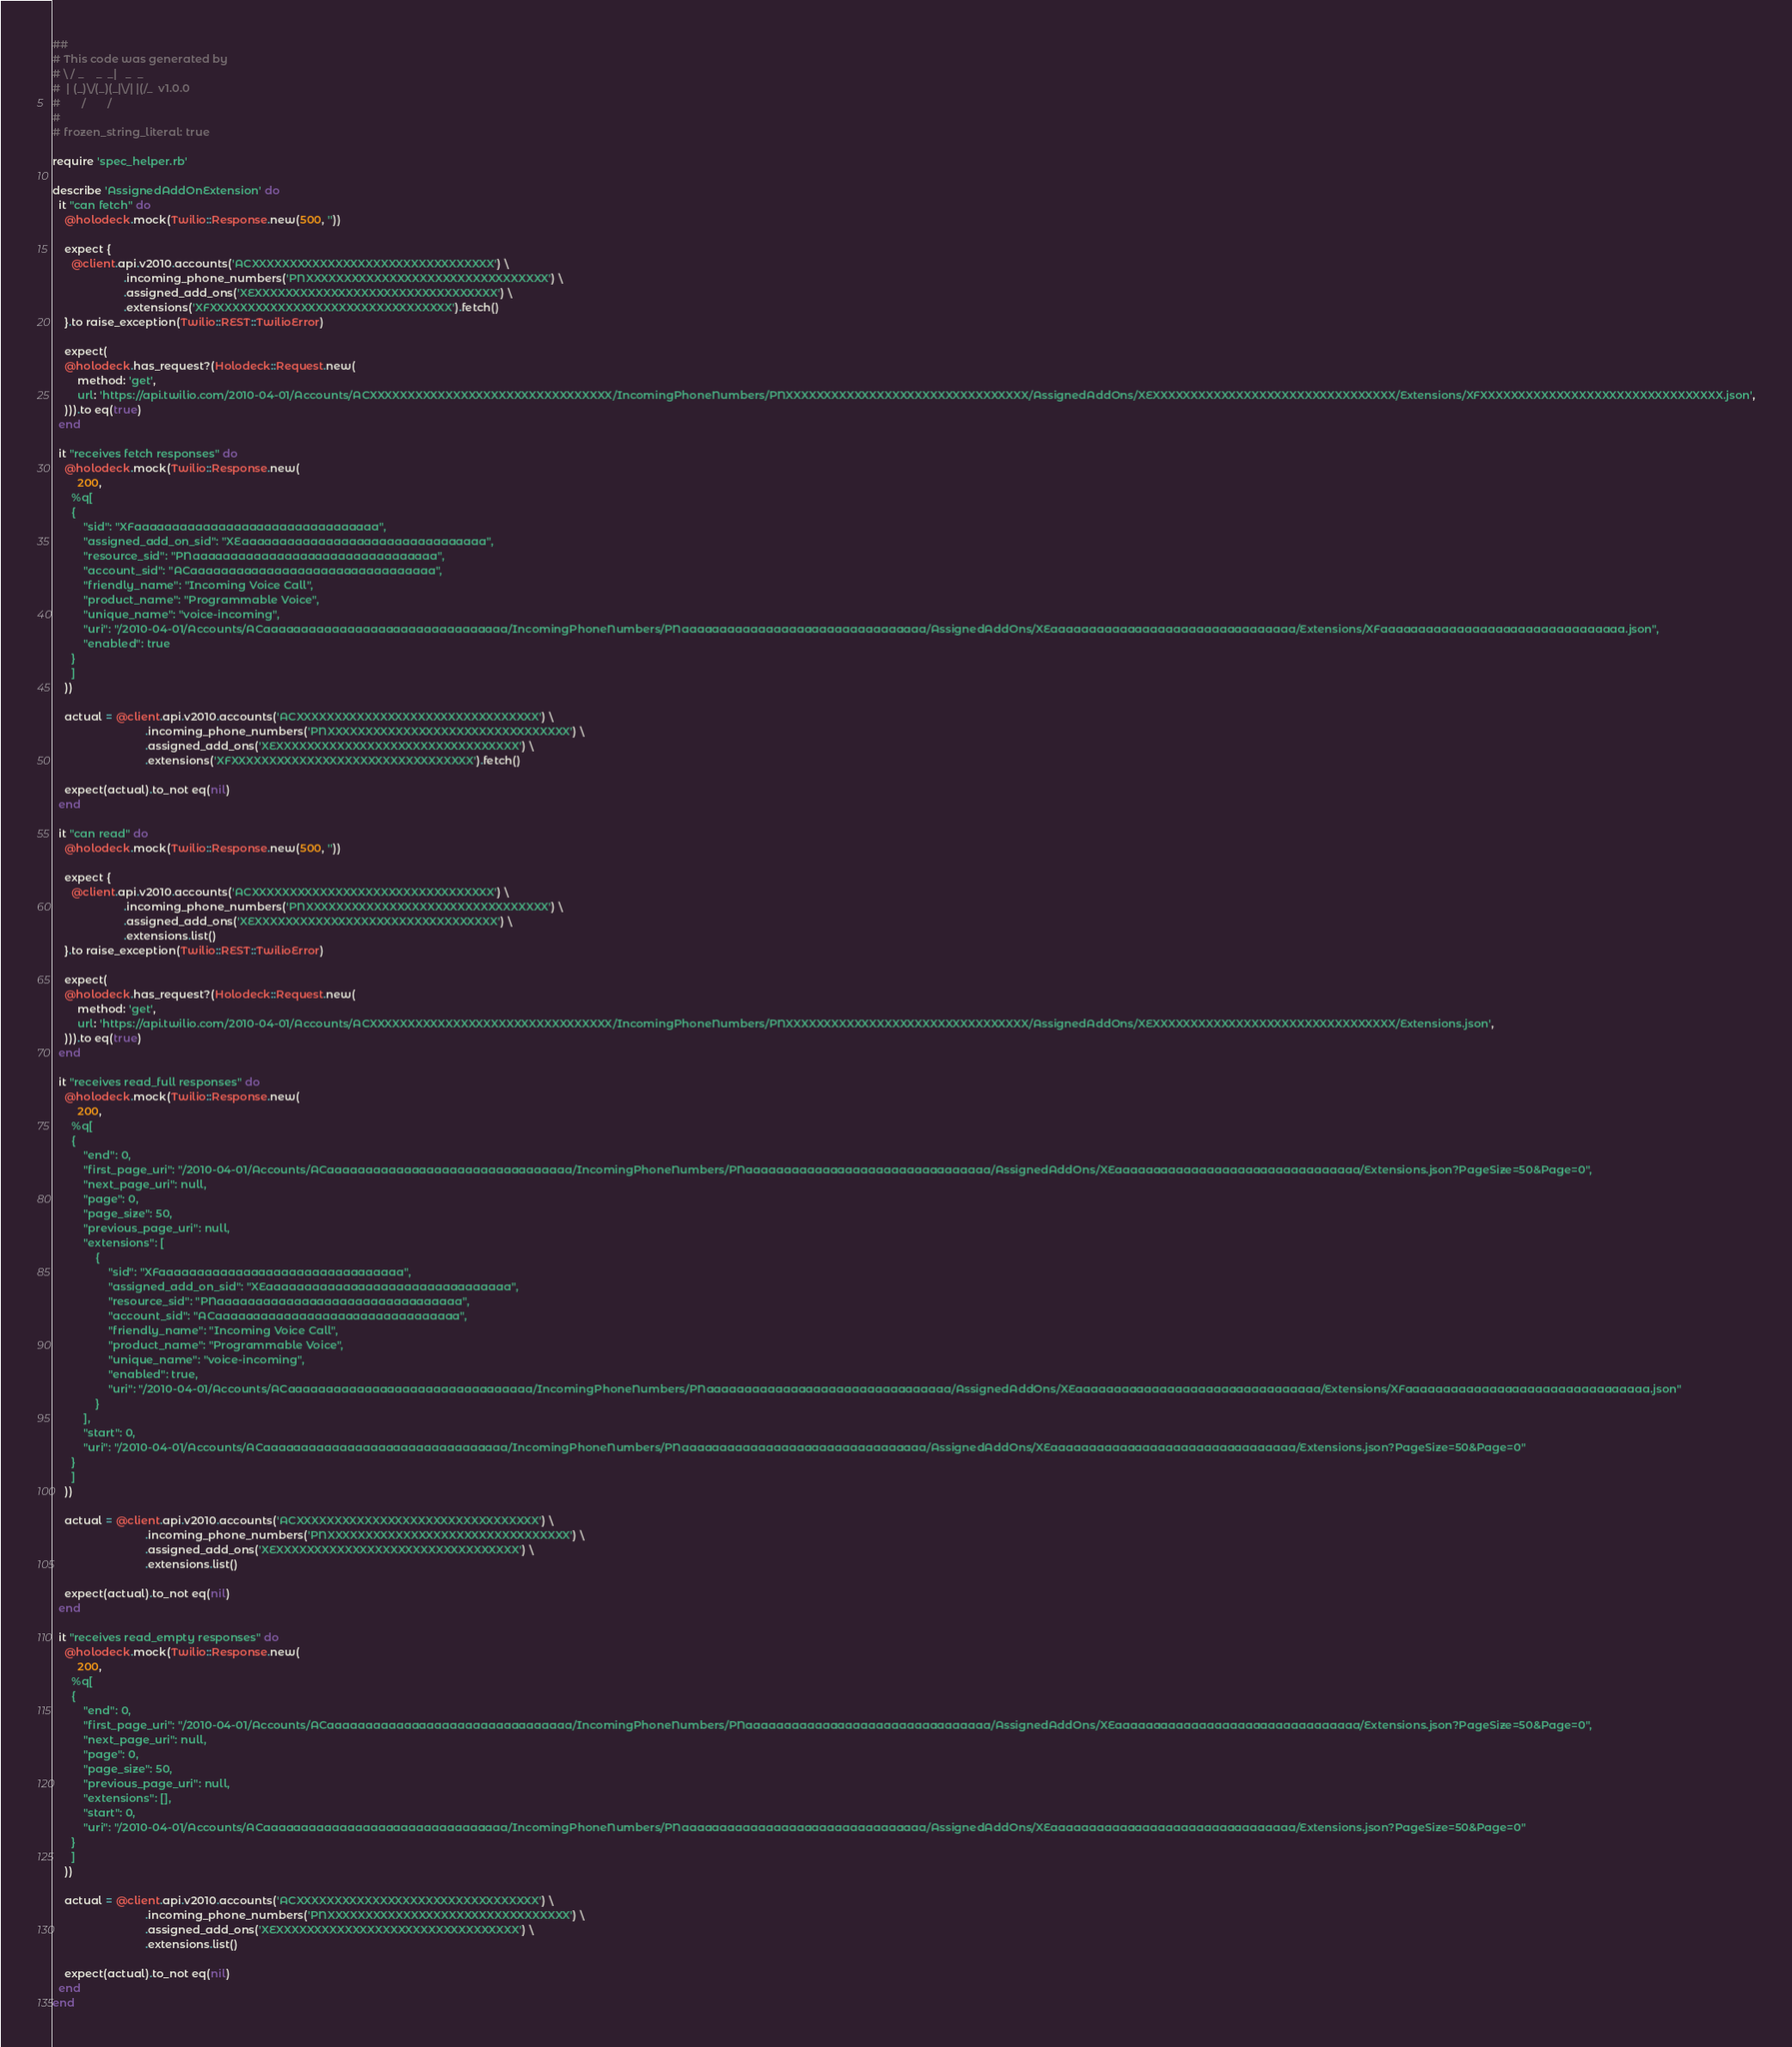Convert code to text. <code><loc_0><loc_0><loc_500><loc_500><_Ruby_>##
# This code was generated by
# \ / _    _  _|   _  _
#  | (_)\/(_)(_|\/| |(/_  v1.0.0
#       /       /
#
# frozen_string_literal: true

require 'spec_helper.rb'

describe 'AssignedAddOnExtension' do
  it "can fetch" do
    @holodeck.mock(Twilio::Response.new(500, ''))

    expect {
      @client.api.v2010.accounts('ACXXXXXXXXXXXXXXXXXXXXXXXXXXXXXXXX') \
                       .incoming_phone_numbers('PNXXXXXXXXXXXXXXXXXXXXXXXXXXXXXXXX') \
                       .assigned_add_ons('XEXXXXXXXXXXXXXXXXXXXXXXXXXXXXXXXX') \
                       .extensions('XFXXXXXXXXXXXXXXXXXXXXXXXXXXXXXXXX').fetch()
    }.to raise_exception(Twilio::REST::TwilioError)

    expect(
    @holodeck.has_request?(Holodeck::Request.new(
        method: 'get',
        url: 'https://api.twilio.com/2010-04-01/Accounts/ACXXXXXXXXXXXXXXXXXXXXXXXXXXXXXXXX/IncomingPhoneNumbers/PNXXXXXXXXXXXXXXXXXXXXXXXXXXXXXXXX/AssignedAddOns/XEXXXXXXXXXXXXXXXXXXXXXXXXXXXXXXXX/Extensions/XFXXXXXXXXXXXXXXXXXXXXXXXXXXXXXXXX.json',
    ))).to eq(true)
  end

  it "receives fetch responses" do
    @holodeck.mock(Twilio::Response.new(
        200,
      %q[
      {
          "sid": "XFaaaaaaaaaaaaaaaaaaaaaaaaaaaaaaaa",
          "assigned_add_on_sid": "XEaaaaaaaaaaaaaaaaaaaaaaaaaaaaaaaa",
          "resource_sid": "PNaaaaaaaaaaaaaaaaaaaaaaaaaaaaaaaa",
          "account_sid": "ACaaaaaaaaaaaaaaaaaaaaaaaaaaaaaaaa",
          "friendly_name": "Incoming Voice Call",
          "product_name": "Programmable Voice",
          "unique_name": "voice-incoming",
          "uri": "/2010-04-01/Accounts/ACaaaaaaaaaaaaaaaaaaaaaaaaaaaaaaaa/IncomingPhoneNumbers/PNaaaaaaaaaaaaaaaaaaaaaaaaaaaaaaaa/AssignedAddOns/XEaaaaaaaaaaaaaaaaaaaaaaaaaaaaaaaa/Extensions/XFaaaaaaaaaaaaaaaaaaaaaaaaaaaaaaaa.json",
          "enabled": true
      }
      ]
    ))

    actual = @client.api.v2010.accounts('ACXXXXXXXXXXXXXXXXXXXXXXXXXXXXXXXX') \
                              .incoming_phone_numbers('PNXXXXXXXXXXXXXXXXXXXXXXXXXXXXXXXX') \
                              .assigned_add_ons('XEXXXXXXXXXXXXXXXXXXXXXXXXXXXXXXXX') \
                              .extensions('XFXXXXXXXXXXXXXXXXXXXXXXXXXXXXXXXX').fetch()

    expect(actual).to_not eq(nil)
  end

  it "can read" do
    @holodeck.mock(Twilio::Response.new(500, ''))

    expect {
      @client.api.v2010.accounts('ACXXXXXXXXXXXXXXXXXXXXXXXXXXXXXXXX') \
                       .incoming_phone_numbers('PNXXXXXXXXXXXXXXXXXXXXXXXXXXXXXXXX') \
                       .assigned_add_ons('XEXXXXXXXXXXXXXXXXXXXXXXXXXXXXXXXX') \
                       .extensions.list()
    }.to raise_exception(Twilio::REST::TwilioError)

    expect(
    @holodeck.has_request?(Holodeck::Request.new(
        method: 'get',
        url: 'https://api.twilio.com/2010-04-01/Accounts/ACXXXXXXXXXXXXXXXXXXXXXXXXXXXXXXXX/IncomingPhoneNumbers/PNXXXXXXXXXXXXXXXXXXXXXXXXXXXXXXXX/AssignedAddOns/XEXXXXXXXXXXXXXXXXXXXXXXXXXXXXXXXX/Extensions.json',
    ))).to eq(true)
  end

  it "receives read_full responses" do
    @holodeck.mock(Twilio::Response.new(
        200,
      %q[
      {
          "end": 0,
          "first_page_uri": "/2010-04-01/Accounts/ACaaaaaaaaaaaaaaaaaaaaaaaaaaaaaaaa/IncomingPhoneNumbers/PNaaaaaaaaaaaaaaaaaaaaaaaaaaaaaaaa/AssignedAddOns/XEaaaaaaaaaaaaaaaaaaaaaaaaaaaaaaaa/Extensions.json?PageSize=50&Page=0",
          "next_page_uri": null,
          "page": 0,
          "page_size": 50,
          "previous_page_uri": null,
          "extensions": [
              {
                  "sid": "XFaaaaaaaaaaaaaaaaaaaaaaaaaaaaaaaa",
                  "assigned_add_on_sid": "XEaaaaaaaaaaaaaaaaaaaaaaaaaaaaaaaa",
                  "resource_sid": "PNaaaaaaaaaaaaaaaaaaaaaaaaaaaaaaaa",
                  "account_sid": "ACaaaaaaaaaaaaaaaaaaaaaaaaaaaaaaaa",
                  "friendly_name": "Incoming Voice Call",
                  "product_name": "Programmable Voice",
                  "unique_name": "voice-incoming",
                  "enabled": true,
                  "uri": "/2010-04-01/Accounts/ACaaaaaaaaaaaaaaaaaaaaaaaaaaaaaaaa/IncomingPhoneNumbers/PNaaaaaaaaaaaaaaaaaaaaaaaaaaaaaaaa/AssignedAddOns/XEaaaaaaaaaaaaaaaaaaaaaaaaaaaaaaaa/Extensions/XFaaaaaaaaaaaaaaaaaaaaaaaaaaaaaaaa.json"
              }
          ],
          "start": 0,
          "uri": "/2010-04-01/Accounts/ACaaaaaaaaaaaaaaaaaaaaaaaaaaaaaaaa/IncomingPhoneNumbers/PNaaaaaaaaaaaaaaaaaaaaaaaaaaaaaaaa/AssignedAddOns/XEaaaaaaaaaaaaaaaaaaaaaaaaaaaaaaaa/Extensions.json?PageSize=50&Page=0"
      }
      ]
    ))

    actual = @client.api.v2010.accounts('ACXXXXXXXXXXXXXXXXXXXXXXXXXXXXXXXX') \
                              .incoming_phone_numbers('PNXXXXXXXXXXXXXXXXXXXXXXXXXXXXXXXX') \
                              .assigned_add_ons('XEXXXXXXXXXXXXXXXXXXXXXXXXXXXXXXXX') \
                              .extensions.list()

    expect(actual).to_not eq(nil)
  end

  it "receives read_empty responses" do
    @holodeck.mock(Twilio::Response.new(
        200,
      %q[
      {
          "end": 0,
          "first_page_uri": "/2010-04-01/Accounts/ACaaaaaaaaaaaaaaaaaaaaaaaaaaaaaaaa/IncomingPhoneNumbers/PNaaaaaaaaaaaaaaaaaaaaaaaaaaaaaaaa/AssignedAddOns/XEaaaaaaaaaaaaaaaaaaaaaaaaaaaaaaaa/Extensions.json?PageSize=50&Page=0",
          "next_page_uri": null,
          "page": 0,
          "page_size": 50,
          "previous_page_uri": null,
          "extensions": [],
          "start": 0,
          "uri": "/2010-04-01/Accounts/ACaaaaaaaaaaaaaaaaaaaaaaaaaaaaaaaa/IncomingPhoneNumbers/PNaaaaaaaaaaaaaaaaaaaaaaaaaaaaaaaa/AssignedAddOns/XEaaaaaaaaaaaaaaaaaaaaaaaaaaaaaaaa/Extensions.json?PageSize=50&Page=0"
      }
      ]
    ))

    actual = @client.api.v2010.accounts('ACXXXXXXXXXXXXXXXXXXXXXXXXXXXXXXXX') \
                              .incoming_phone_numbers('PNXXXXXXXXXXXXXXXXXXXXXXXXXXXXXXXX') \
                              .assigned_add_ons('XEXXXXXXXXXXXXXXXXXXXXXXXXXXXXXXXX') \
                              .extensions.list()

    expect(actual).to_not eq(nil)
  end
end</code> 